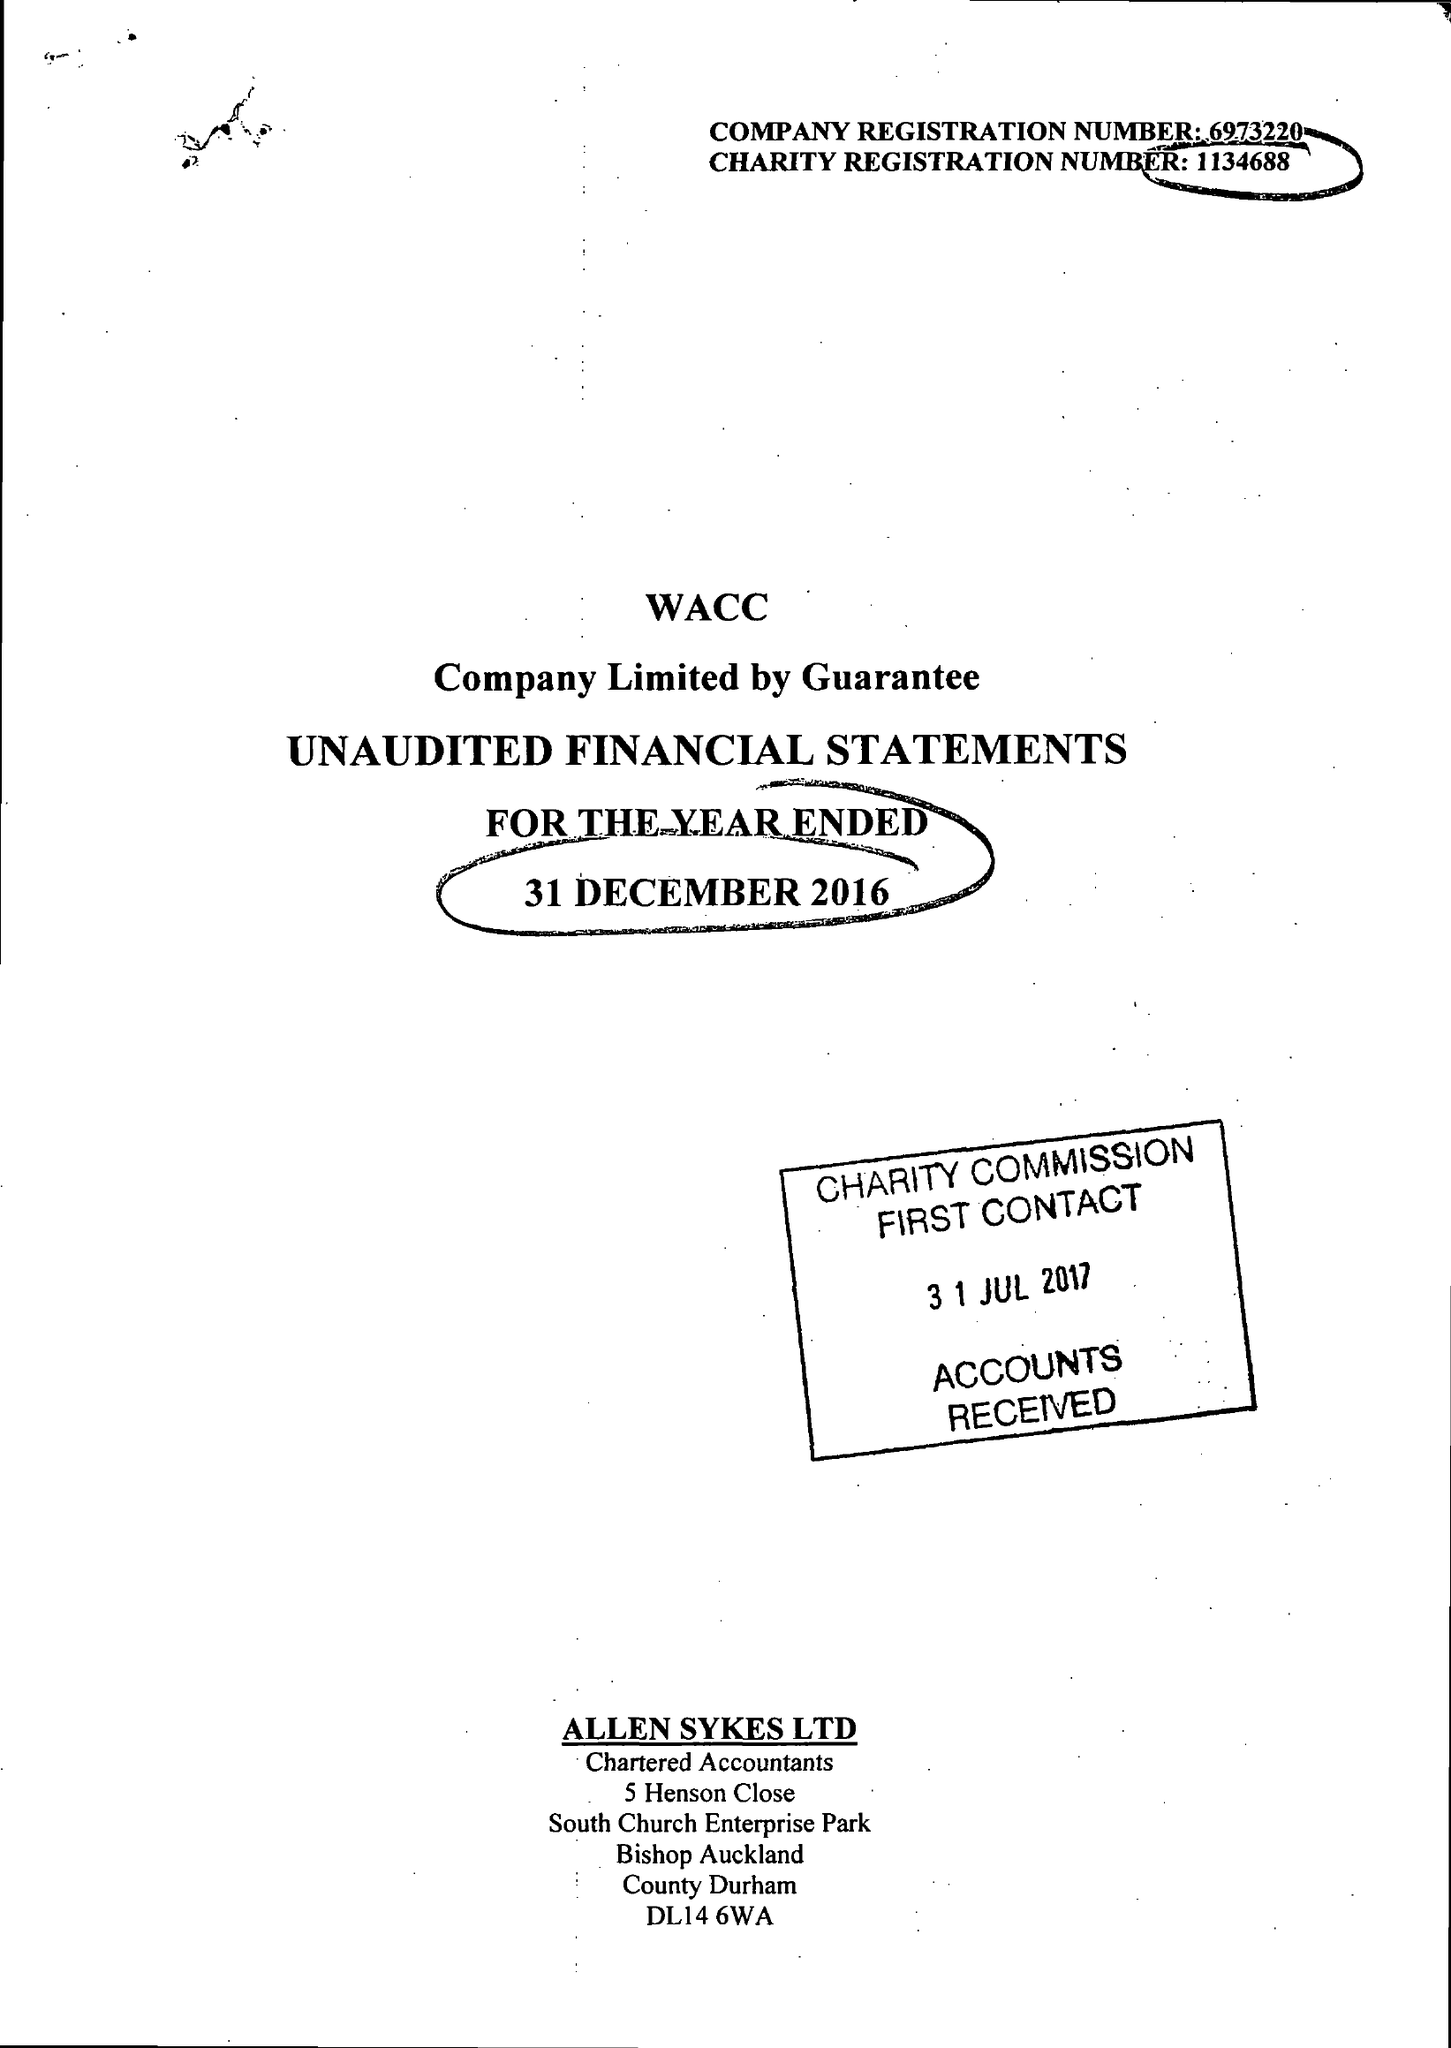What is the value for the address__street_line?
Answer the question using a single word or phrase. None 